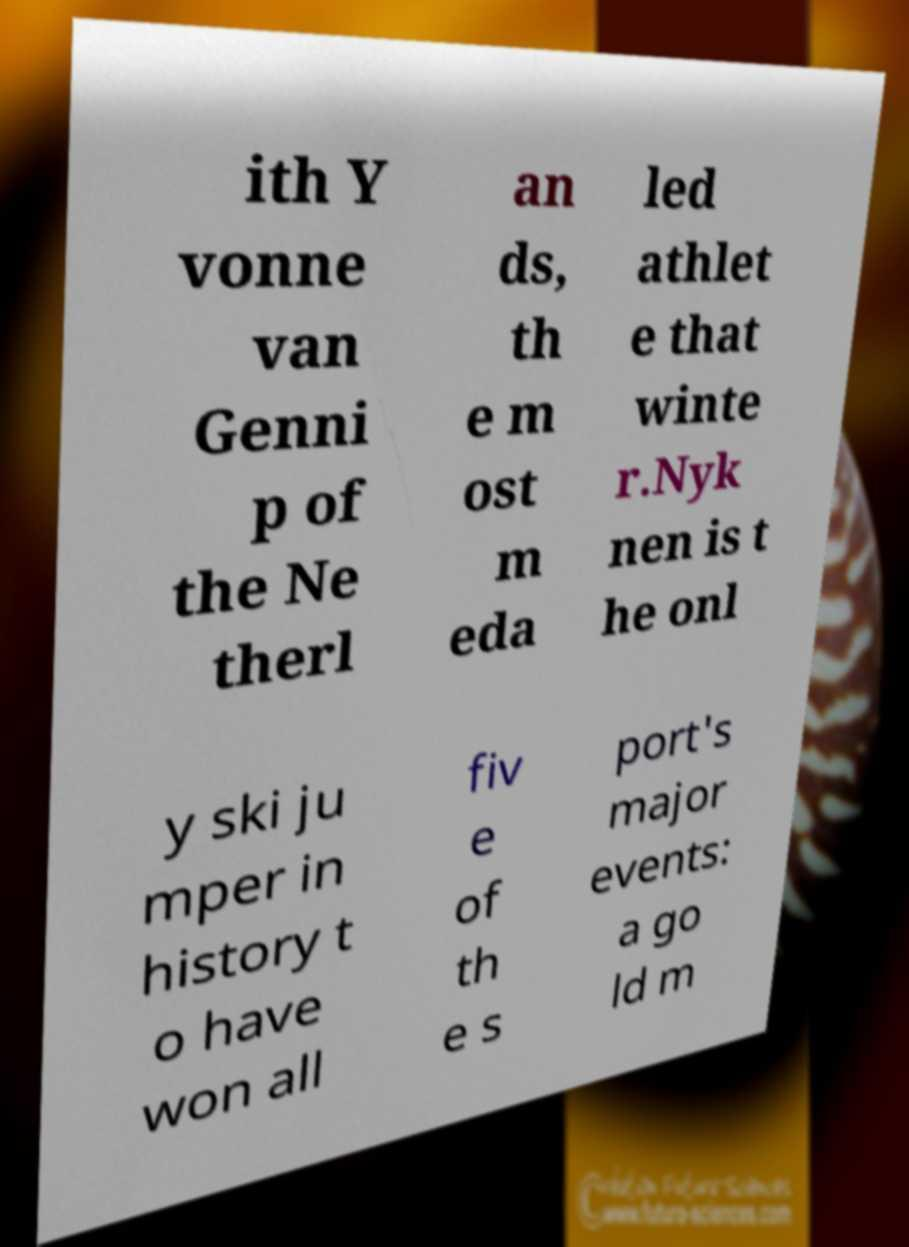What messages or text are displayed in this image? I need them in a readable, typed format. ith Y vonne van Genni p of the Ne therl an ds, th e m ost m eda led athlet e that winte r.Nyk nen is t he onl y ski ju mper in history t o have won all fiv e of th e s port's major events: a go ld m 